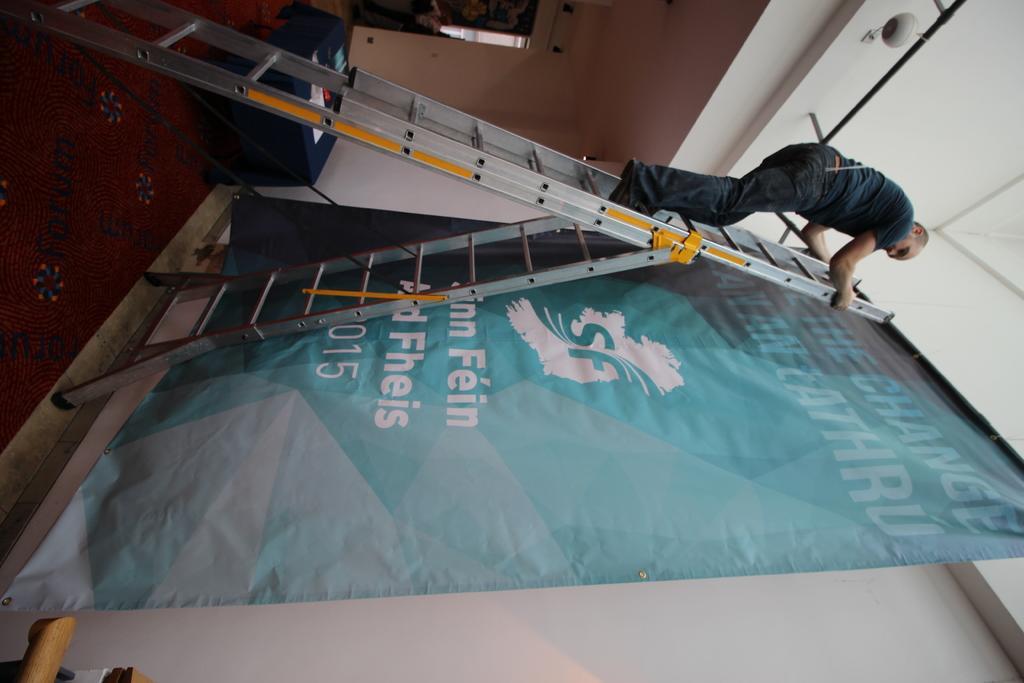Describe this image in one or two sentences. There is a ladder. On that a person is standing. Near to the ladder there is a wall. On that there is a banner on the stand. On the floor there is a carpet. Also there is a table. 